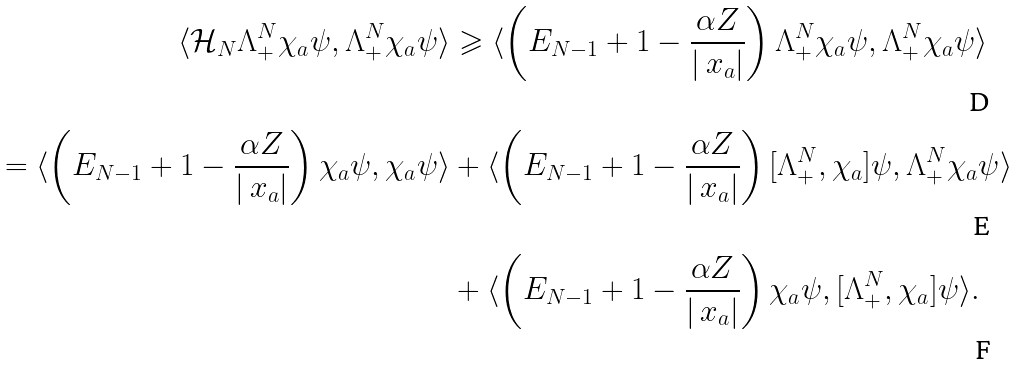Convert formula to latex. <formula><loc_0><loc_0><loc_500><loc_500>\langle \mathcal { H } _ { N } \Lambda _ { + } ^ { N } \chi _ { a } \psi , \Lambda _ { + } ^ { N } \chi _ { a } \psi \rangle & \geqslant \langle \left ( E _ { N - 1 } + 1 - \frac { \alpha Z } { | \ x _ { a } | } \right ) \Lambda ^ { N } _ { + } \chi _ { a } \psi , \Lambda _ { + } ^ { N } \chi _ { a } \psi \rangle \\ = \langle \left ( E _ { N - 1 } + 1 - \frac { \alpha Z } { | \ x _ { a } | } \right ) \chi _ { a } \psi , \chi _ { a } \psi \rangle & + \langle \left ( E _ { N - 1 } + 1 - \frac { \alpha Z } { | \ x _ { a } | } \right ) [ \Lambda ^ { N } _ { + } , \chi _ { a } ] \psi , \Lambda _ { + } ^ { N } \chi _ { a } \psi \rangle \\ & + \langle \left ( E _ { N - 1 } + 1 - \frac { \alpha Z } { | \ x _ { a } | } \right ) \chi _ { a } \psi , [ \Lambda _ { + } ^ { N } , \chi _ { a } ] \psi \rangle .</formula> 